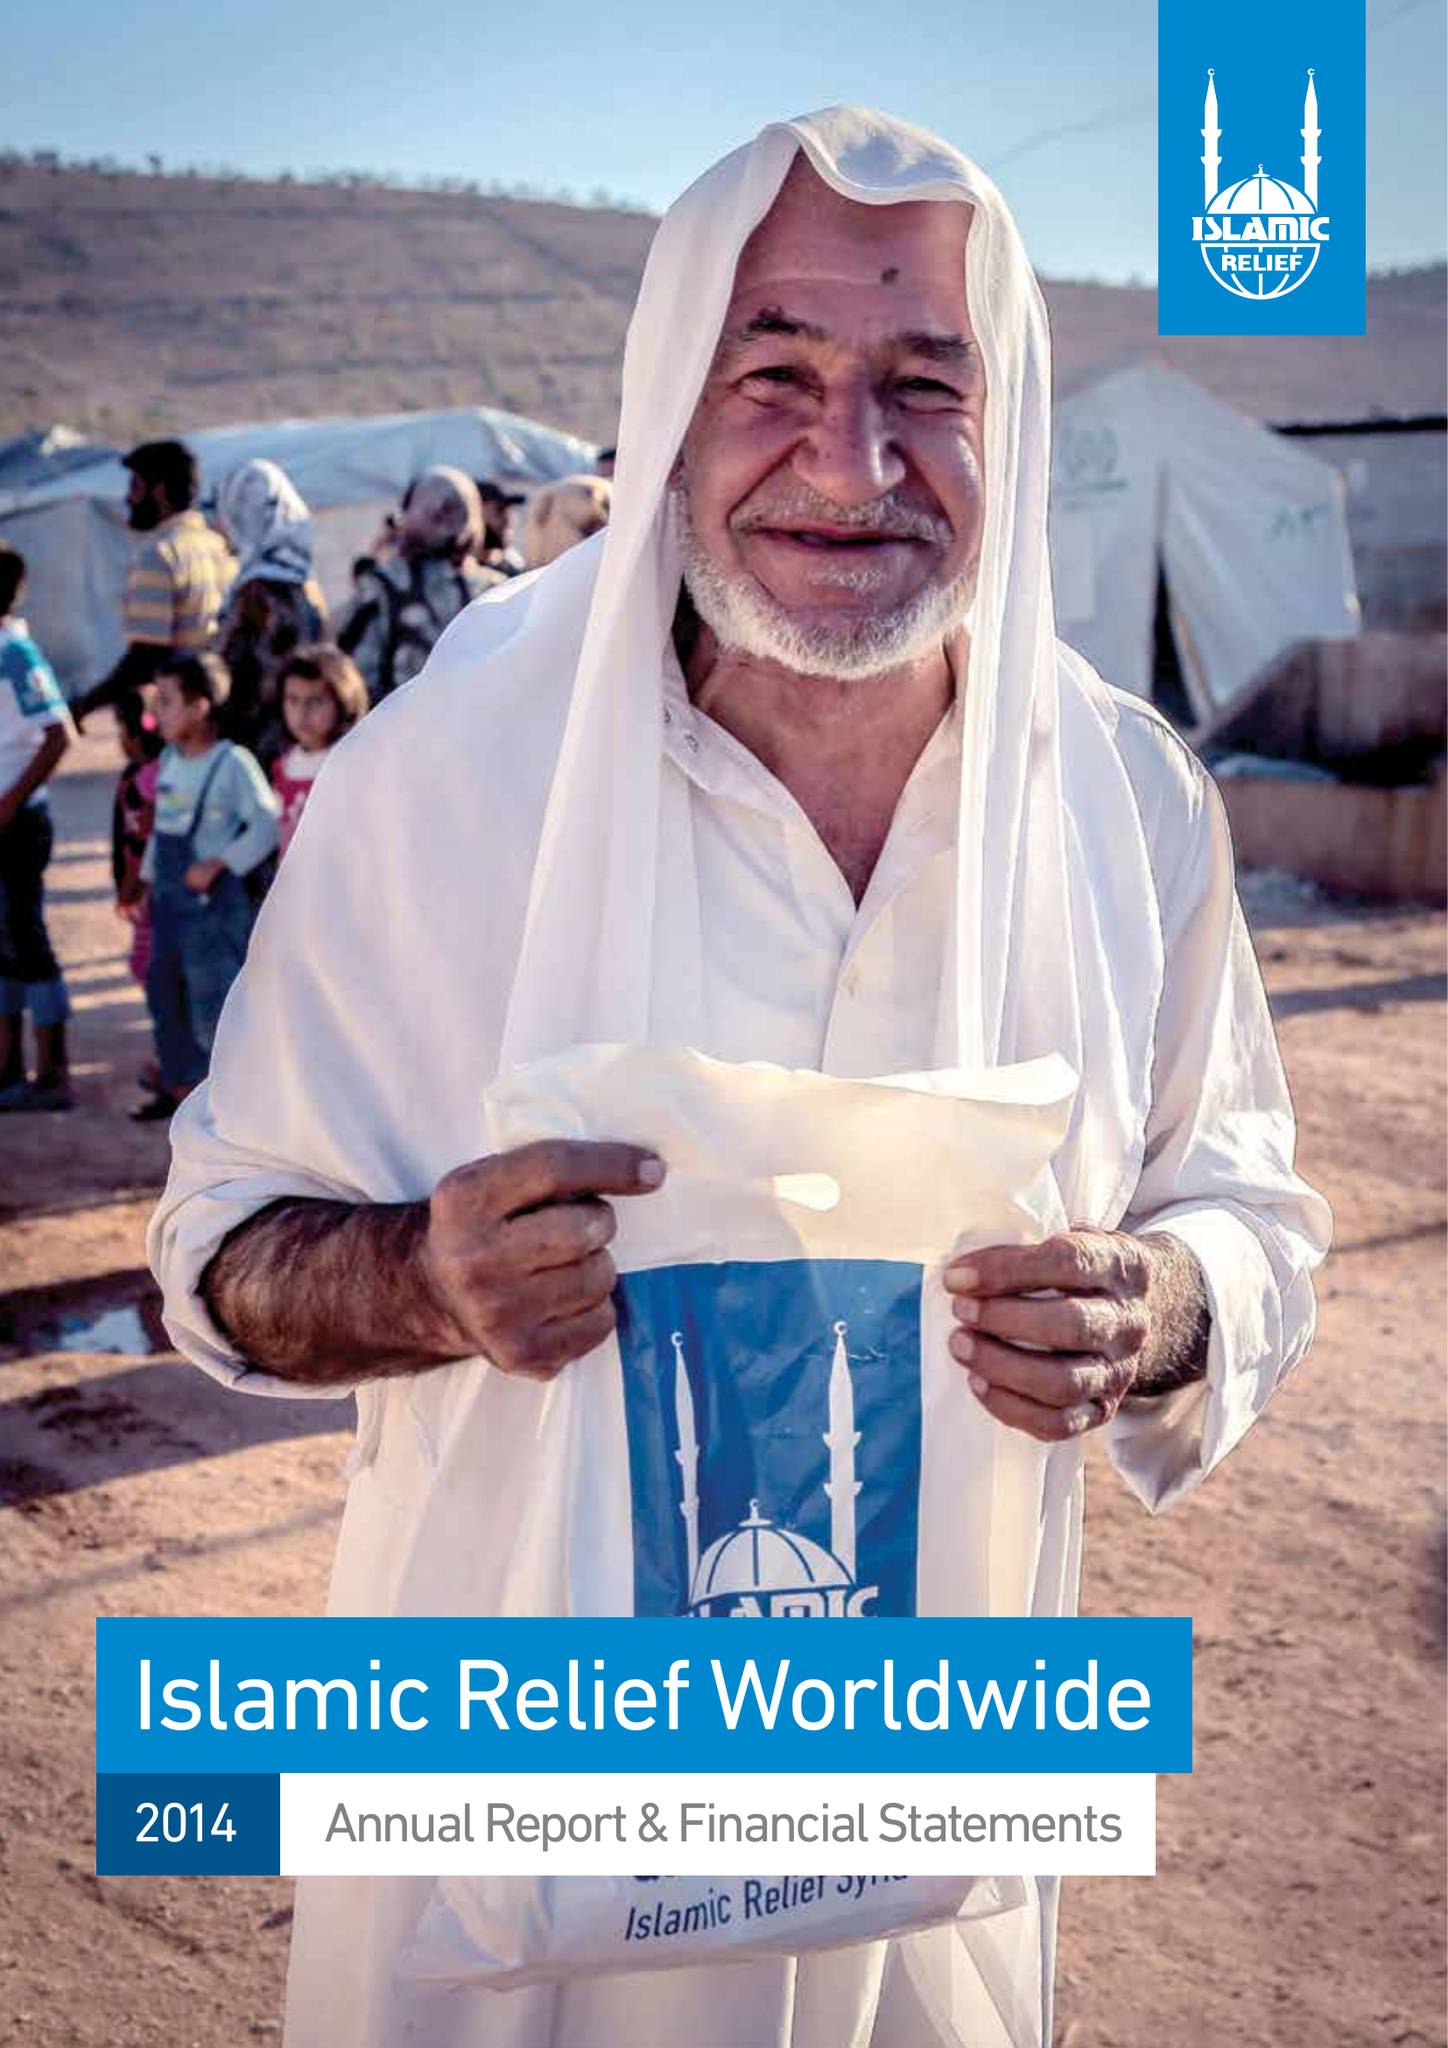What is the value for the address__post_town?
Answer the question using a single word or phrase. BIRMINGHAM 